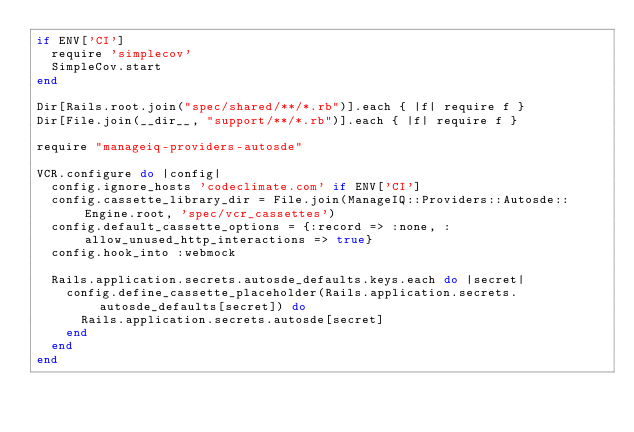Convert code to text. <code><loc_0><loc_0><loc_500><loc_500><_Ruby_>if ENV['CI']
  require 'simplecov'
  SimpleCov.start
end

Dir[Rails.root.join("spec/shared/**/*.rb")].each { |f| require f }
Dir[File.join(__dir__, "support/**/*.rb")].each { |f| require f }

require "manageiq-providers-autosde"

VCR.configure do |config|
  config.ignore_hosts 'codeclimate.com' if ENV['CI']
  config.cassette_library_dir = File.join(ManageIQ::Providers::Autosde::Engine.root, 'spec/vcr_cassettes')
  config.default_cassette_options = {:record => :none, :allow_unused_http_interactions => true}
  config.hook_into :webmock

  Rails.application.secrets.autosde_defaults.keys.each do |secret|
    config.define_cassette_placeholder(Rails.application.secrets.autosde_defaults[secret]) do
      Rails.application.secrets.autosde[secret]
    end
  end
end
</code> 